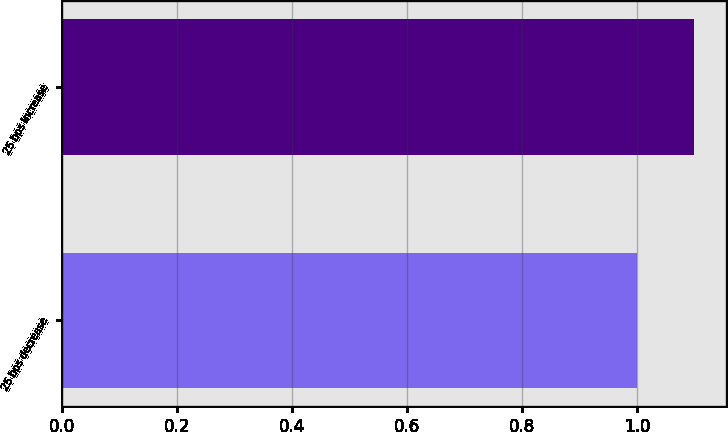Convert chart to OTSL. <chart><loc_0><loc_0><loc_500><loc_500><bar_chart><fcel>25 bps decrease<fcel>25 bps increase<nl><fcel>1<fcel>1.1<nl></chart> 